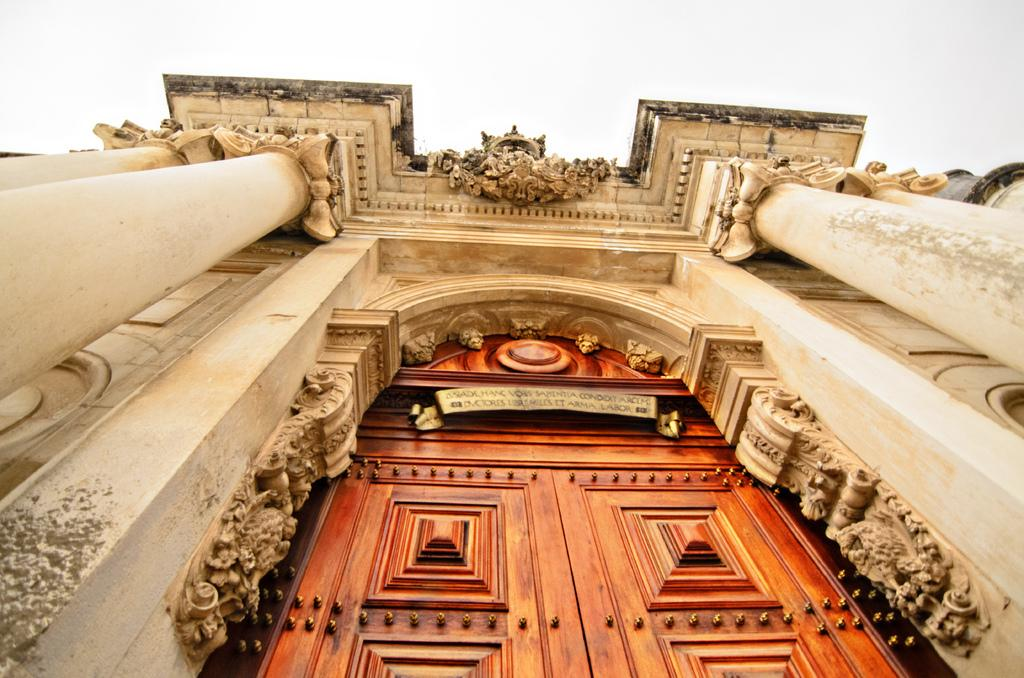What is one of the main features of the image? There is a door in the image. What color is the door? The door is brown in color. What type of structure is visible in the image? There is a building in the image. What color is the background of the image? The background of the image is white. What type of quartz can be seen on the door in the image? There is no quartz present on the door in the image. Can you describe how the door is smashed in the image? The door is not smashed in the image; it appears to be intact. 